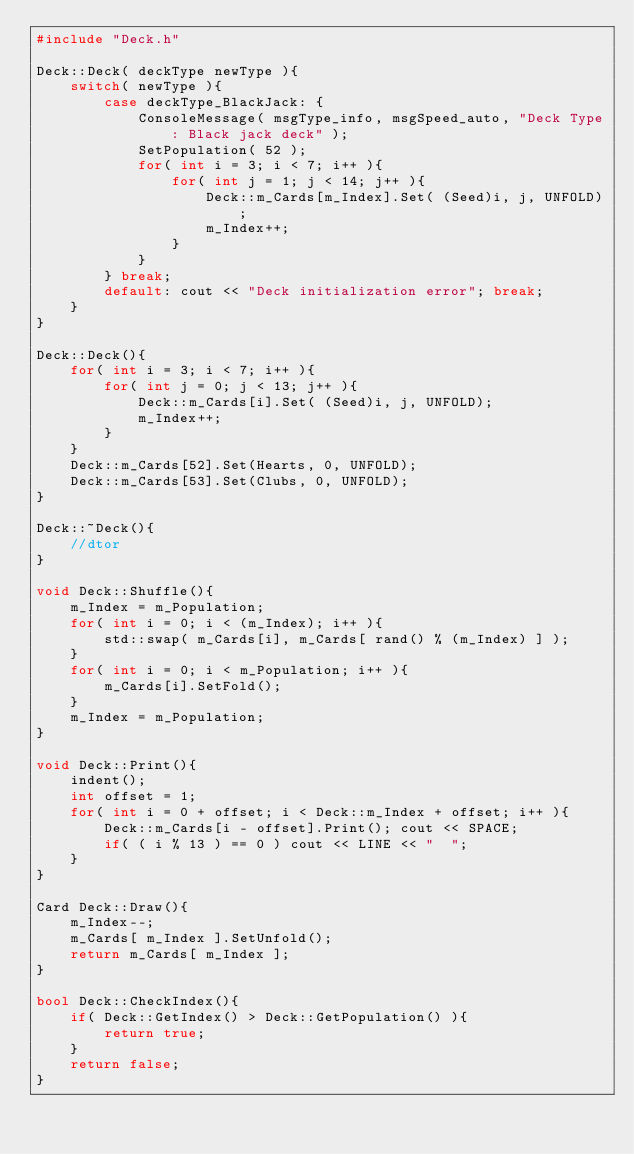<code> <loc_0><loc_0><loc_500><loc_500><_C++_>#include "Deck.h"

Deck::Deck( deckType newType ){
    switch( newType ){
        case deckType_BlackJack: {
            ConsoleMessage( msgType_info, msgSpeed_auto, "Deck Type: Black jack deck" );
            SetPopulation( 52 );
            for( int i = 3; i < 7; i++ ){
                for( int j = 1; j < 14; j++ ){
                    Deck::m_Cards[m_Index].Set( (Seed)i, j, UNFOLD);
                    m_Index++;
                }
            }
        } break;
        default: cout << "Deck initialization error"; break;
    }
}

Deck::Deck(){
    for( int i = 3; i < 7; i++ ){
        for( int j = 0; j < 13; j++ ){
            Deck::m_Cards[i].Set( (Seed)i, j, UNFOLD);
            m_Index++;
        }
    }
    Deck::m_Cards[52].Set(Hearts, 0, UNFOLD);
    Deck::m_Cards[53].Set(Clubs, 0, UNFOLD);
}

Deck::~Deck(){
    //dtor
}

void Deck::Shuffle(){
    m_Index = m_Population;
    for( int i = 0; i < (m_Index); i++ ){
        std::swap( m_Cards[i], m_Cards[ rand() % (m_Index) ] );
    }
    for( int i = 0; i < m_Population; i++ ){
        m_Cards[i].SetFold();
    }
    m_Index = m_Population;
}

void Deck::Print(){
    indent();
    int offset = 1;
    for( int i = 0 + offset; i < Deck::m_Index + offset; i++ ){
        Deck::m_Cards[i - offset].Print(); cout << SPACE;
        if( ( i % 13 ) == 0 ) cout << LINE << "  ";
    }
}

Card Deck::Draw(){
    m_Index--;
    m_Cards[ m_Index ].SetUnfold();
    return m_Cards[ m_Index ];
}

bool Deck::CheckIndex(){
    if( Deck::GetIndex() > Deck::GetPopulation() ){
        return true;
    }
    return false;
}
</code> 